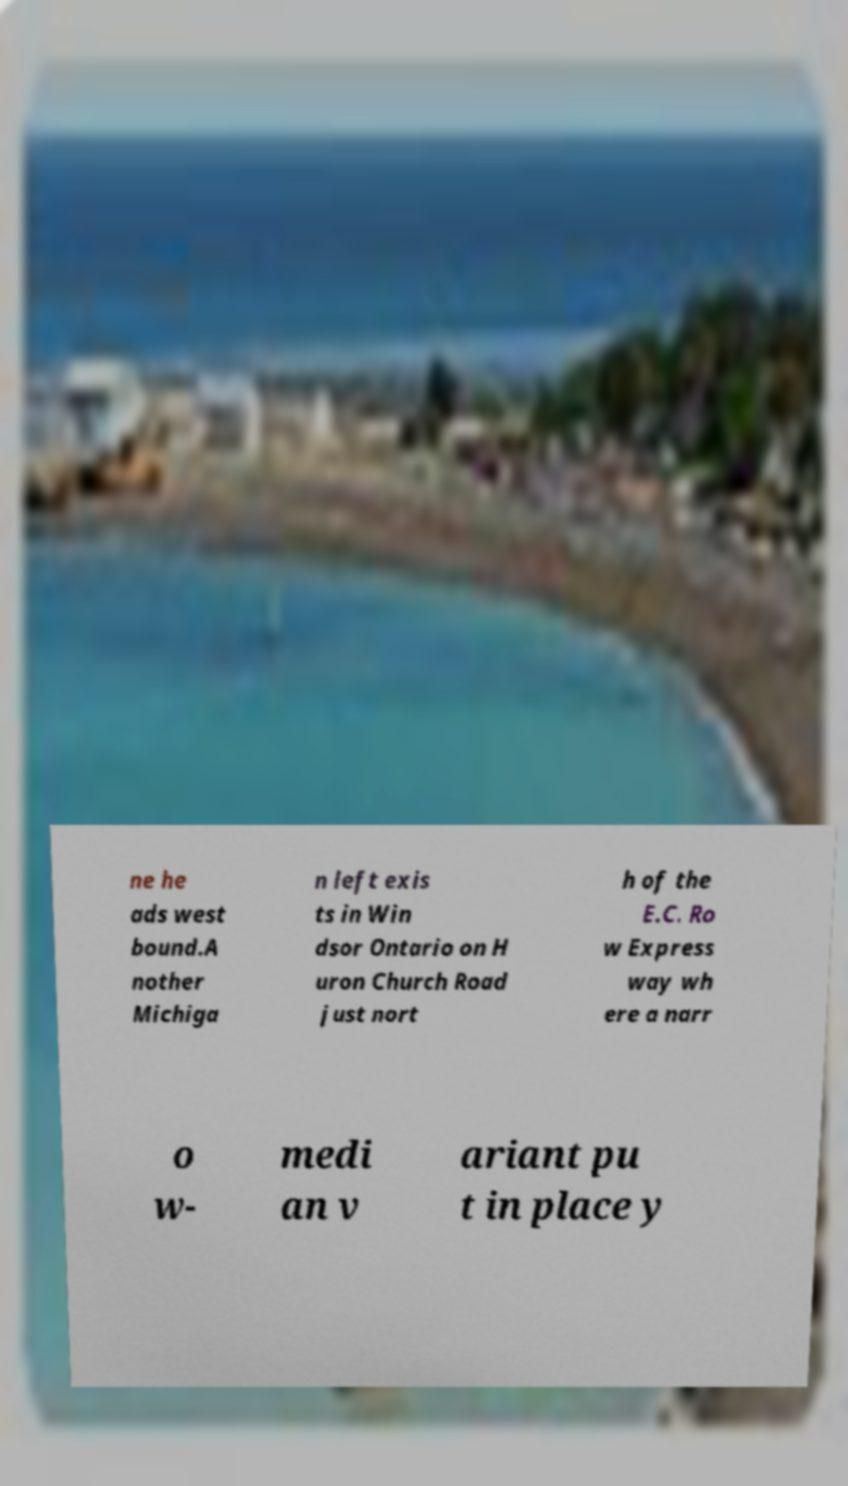Could you assist in decoding the text presented in this image and type it out clearly? ne he ads west bound.A nother Michiga n left exis ts in Win dsor Ontario on H uron Church Road just nort h of the E.C. Ro w Express way wh ere a narr o w- medi an v ariant pu t in place y 